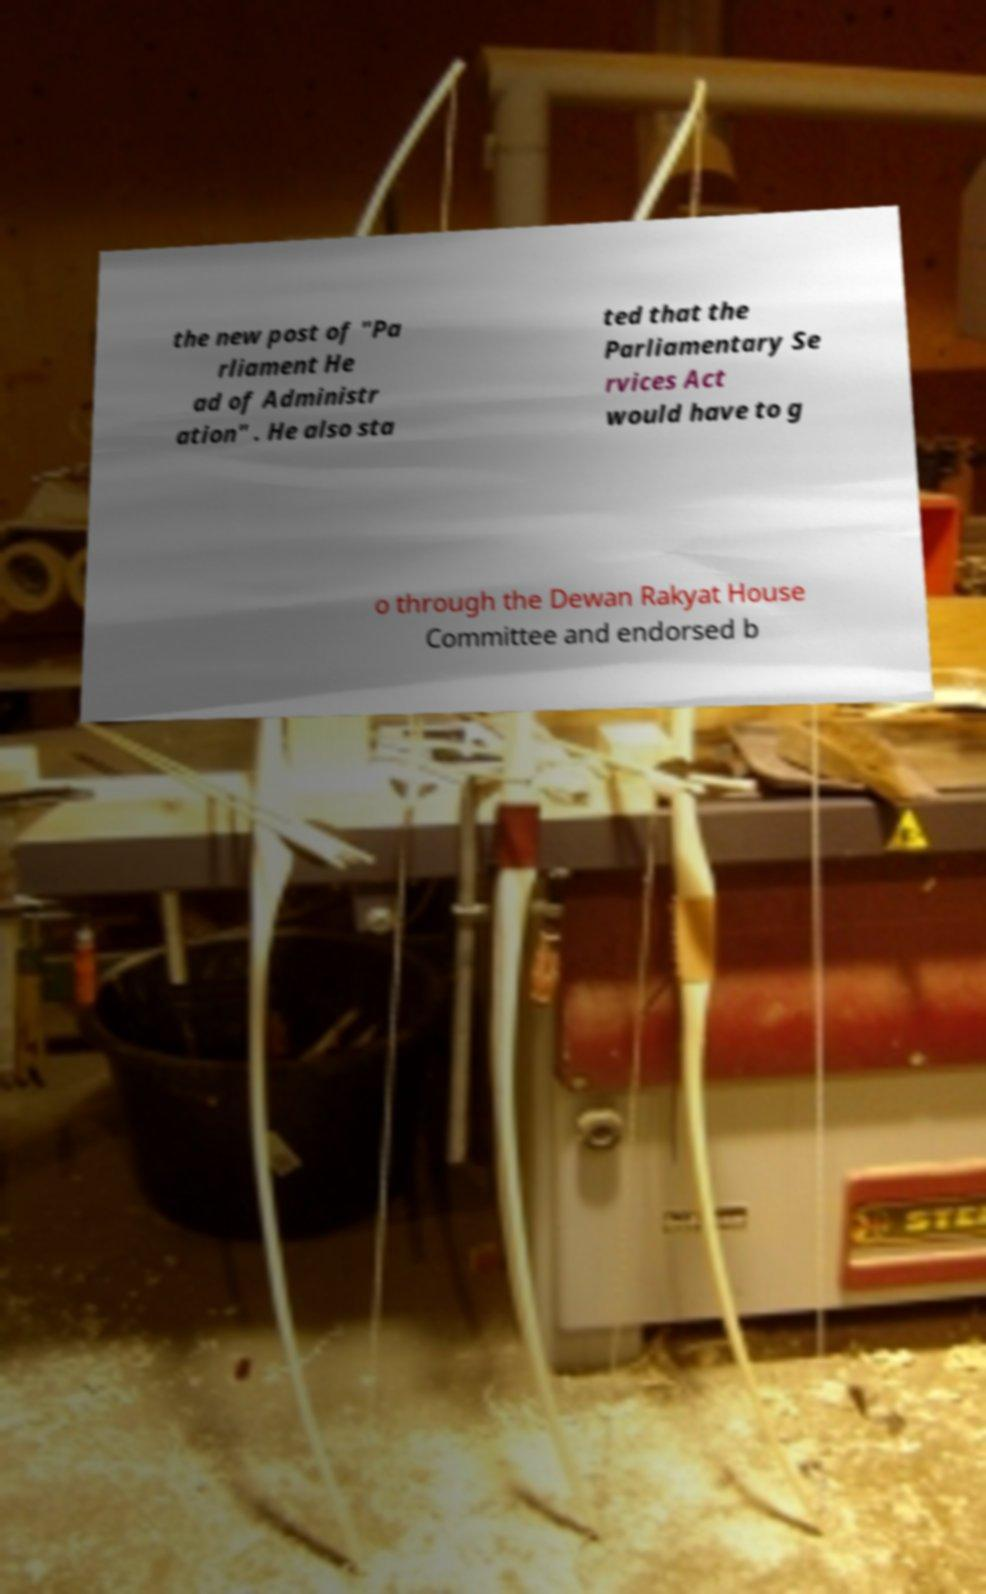For documentation purposes, I need the text within this image transcribed. Could you provide that? the new post of "Pa rliament He ad of Administr ation" . He also sta ted that the Parliamentary Se rvices Act would have to g o through the Dewan Rakyat House Committee and endorsed b 